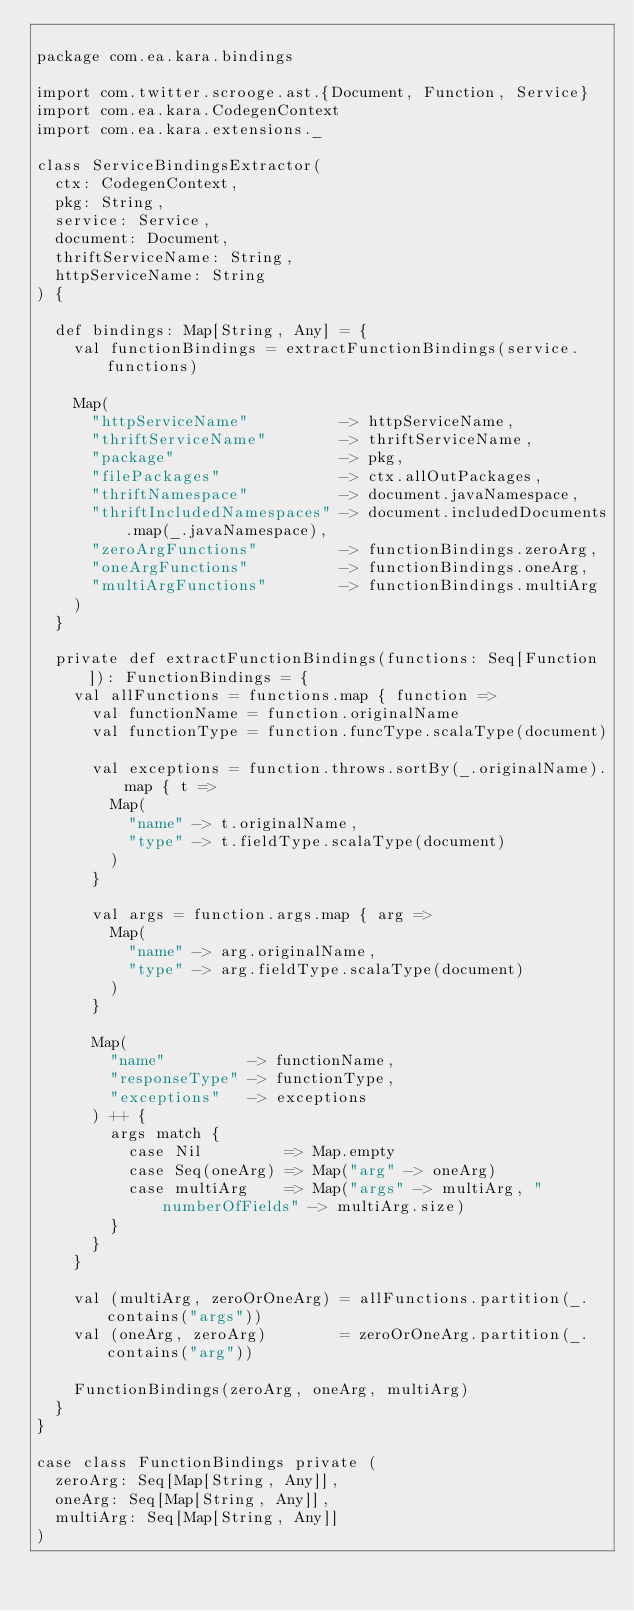Convert code to text. <code><loc_0><loc_0><loc_500><loc_500><_Scala_>
package com.ea.kara.bindings

import com.twitter.scrooge.ast.{Document, Function, Service}
import com.ea.kara.CodegenContext
import com.ea.kara.extensions._

class ServiceBindingsExtractor(
  ctx: CodegenContext,
  pkg: String,
  service: Service,
  document: Document,
  thriftServiceName: String,
  httpServiceName: String
) {

  def bindings: Map[String, Any] = {
    val functionBindings = extractFunctionBindings(service.functions)

    Map(
      "httpServiceName"          -> httpServiceName,
      "thriftServiceName"        -> thriftServiceName,
      "package"                  -> pkg,
      "filePackages"             -> ctx.allOutPackages,
      "thriftNamespace"          -> document.javaNamespace,
      "thriftIncludedNamespaces" -> document.includedDocuments.map(_.javaNamespace),
      "zeroArgFunctions"         -> functionBindings.zeroArg,
      "oneArgFunctions"          -> functionBindings.oneArg,
      "multiArgFunctions"        -> functionBindings.multiArg
    )
  }

  private def extractFunctionBindings(functions: Seq[Function]): FunctionBindings = {
    val allFunctions = functions.map { function =>
      val functionName = function.originalName
      val functionType = function.funcType.scalaType(document)

      val exceptions = function.throws.sortBy(_.originalName).map { t =>
        Map(
          "name" -> t.originalName,
          "type" -> t.fieldType.scalaType(document)
        )
      }

      val args = function.args.map { arg =>
        Map(
          "name" -> arg.originalName,
          "type" -> arg.fieldType.scalaType(document)
        )
      }

      Map(
        "name"         -> functionName,
        "responseType" -> functionType,
        "exceptions"   -> exceptions
      ) ++ {
        args match {
          case Nil         => Map.empty
          case Seq(oneArg) => Map("arg" -> oneArg)
          case multiArg    => Map("args" -> multiArg, "numberOfFields" -> multiArg.size)
        }
      }
    }

    val (multiArg, zeroOrOneArg) = allFunctions.partition(_.contains("args"))
    val (oneArg, zeroArg)        = zeroOrOneArg.partition(_.contains("arg"))

    FunctionBindings(zeroArg, oneArg, multiArg)
  }
}

case class FunctionBindings private (
  zeroArg: Seq[Map[String, Any]],
  oneArg: Seq[Map[String, Any]],
  multiArg: Seq[Map[String, Any]]
)
</code> 